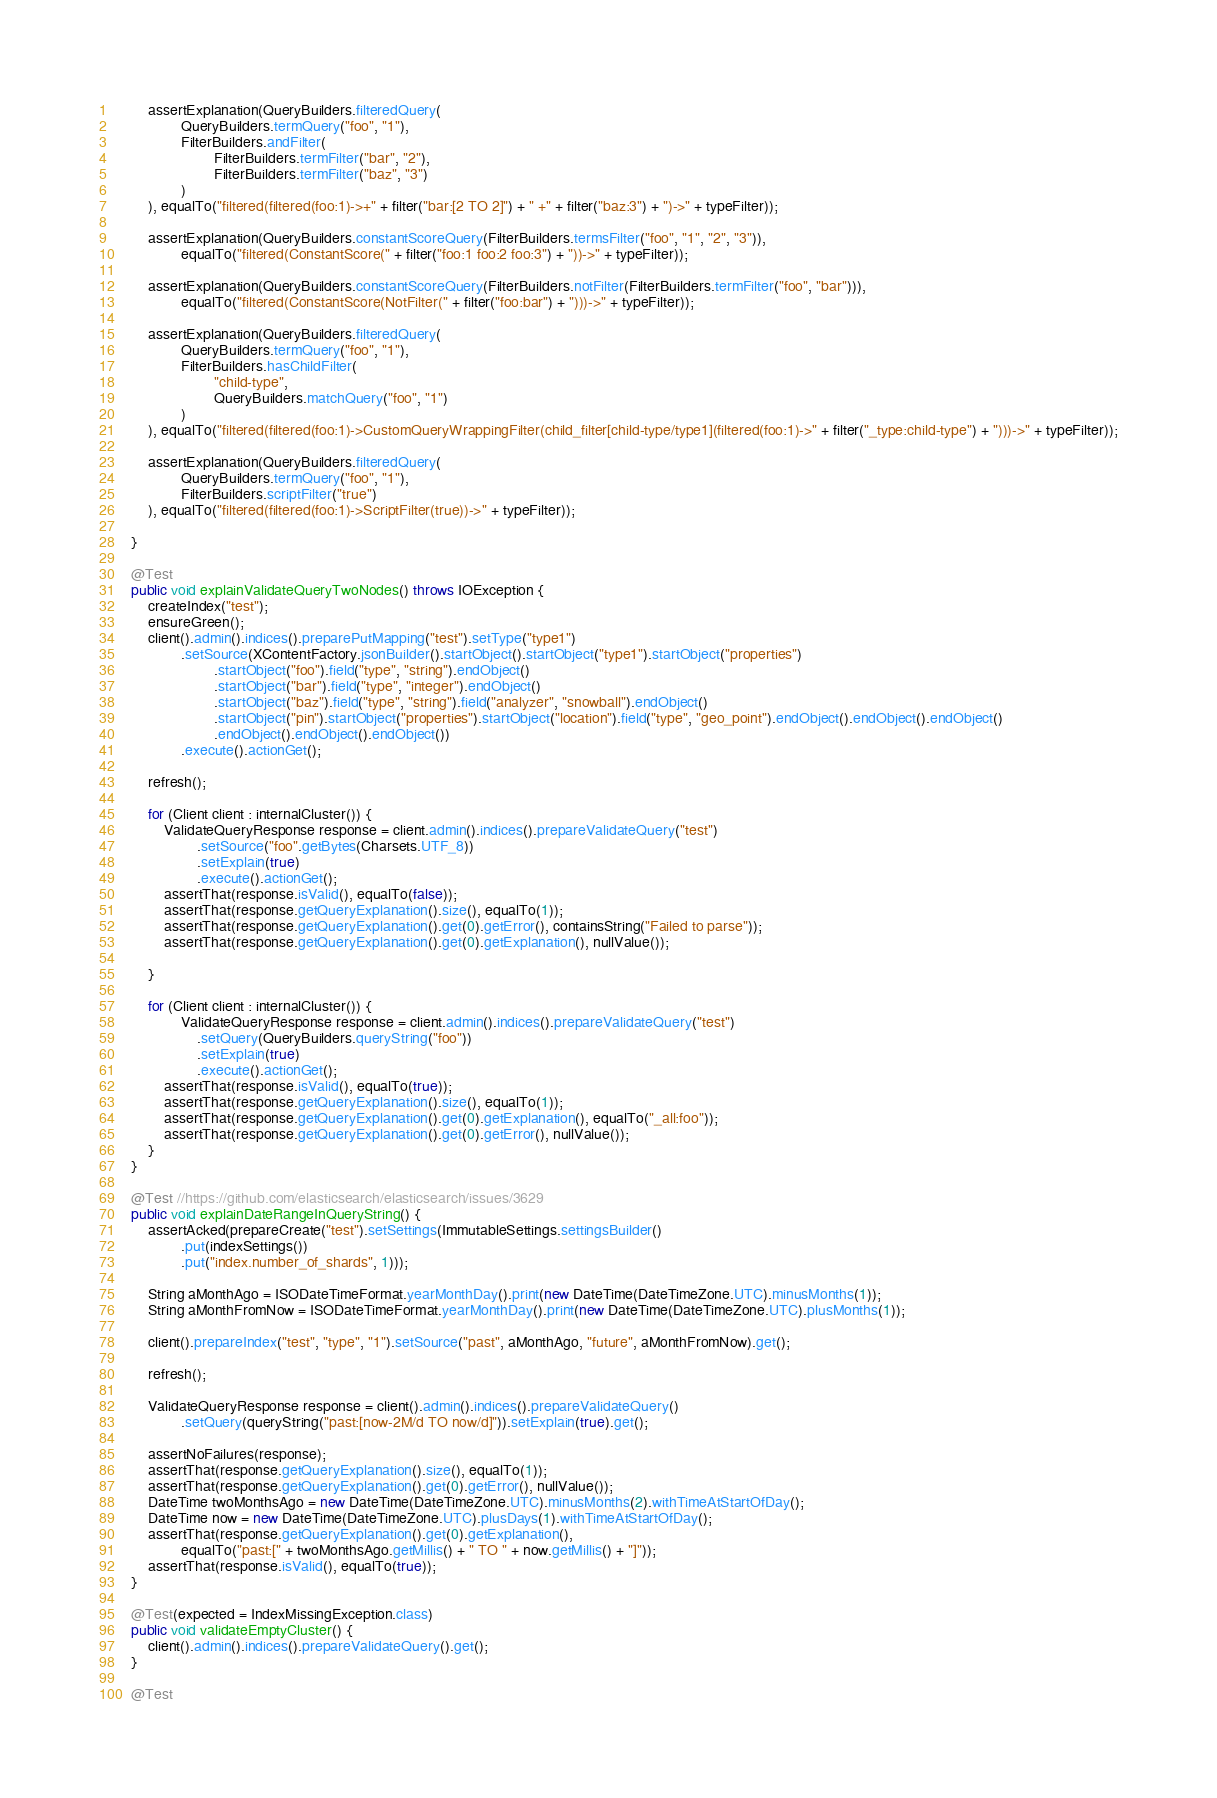<code> <loc_0><loc_0><loc_500><loc_500><_Java_>        assertExplanation(QueryBuilders.filteredQuery(
                QueryBuilders.termQuery("foo", "1"),
                FilterBuilders.andFilter(
                        FilterBuilders.termFilter("bar", "2"),
                        FilterBuilders.termFilter("baz", "3")
                )
        ), equalTo("filtered(filtered(foo:1)->+" + filter("bar:[2 TO 2]") + " +" + filter("baz:3") + ")->" + typeFilter));

        assertExplanation(QueryBuilders.constantScoreQuery(FilterBuilders.termsFilter("foo", "1", "2", "3")),
                equalTo("filtered(ConstantScore(" + filter("foo:1 foo:2 foo:3") + "))->" + typeFilter));

        assertExplanation(QueryBuilders.constantScoreQuery(FilterBuilders.notFilter(FilterBuilders.termFilter("foo", "bar"))),
                equalTo("filtered(ConstantScore(NotFilter(" + filter("foo:bar") + ")))->" + typeFilter));

        assertExplanation(QueryBuilders.filteredQuery(
                QueryBuilders.termQuery("foo", "1"),
                FilterBuilders.hasChildFilter(
                        "child-type",
                        QueryBuilders.matchQuery("foo", "1")
                )
        ), equalTo("filtered(filtered(foo:1)->CustomQueryWrappingFilter(child_filter[child-type/type1](filtered(foo:1)->" + filter("_type:child-type") + ")))->" + typeFilter));

        assertExplanation(QueryBuilders.filteredQuery(
                QueryBuilders.termQuery("foo", "1"),
                FilterBuilders.scriptFilter("true")
        ), equalTo("filtered(filtered(foo:1)->ScriptFilter(true))->" + typeFilter));

    }

    @Test
    public void explainValidateQueryTwoNodes() throws IOException {
        createIndex("test");
        ensureGreen();
        client().admin().indices().preparePutMapping("test").setType("type1")
                .setSource(XContentFactory.jsonBuilder().startObject().startObject("type1").startObject("properties")
                        .startObject("foo").field("type", "string").endObject()
                        .startObject("bar").field("type", "integer").endObject()
                        .startObject("baz").field("type", "string").field("analyzer", "snowball").endObject()
                        .startObject("pin").startObject("properties").startObject("location").field("type", "geo_point").endObject().endObject().endObject()
                        .endObject().endObject().endObject())
                .execute().actionGet();

        refresh();

        for (Client client : internalCluster()) {
            ValidateQueryResponse response = client.admin().indices().prepareValidateQuery("test")
                    .setSource("foo".getBytes(Charsets.UTF_8))
                    .setExplain(true)
                    .execute().actionGet();
            assertThat(response.isValid(), equalTo(false));
            assertThat(response.getQueryExplanation().size(), equalTo(1));
            assertThat(response.getQueryExplanation().get(0).getError(), containsString("Failed to parse"));
            assertThat(response.getQueryExplanation().get(0).getExplanation(), nullValue());

        }
        
        for (Client client : internalCluster()) {
                ValidateQueryResponse response = client.admin().indices().prepareValidateQuery("test")
                    .setQuery(QueryBuilders.queryString("foo"))
                    .setExplain(true)
                    .execute().actionGet();
            assertThat(response.isValid(), equalTo(true));
            assertThat(response.getQueryExplanation().size(), equalTo(1));
            assertThat(response.getQueryExplanation().get(0).getExplanation(), equalTo("_all:foo"));
            assertThat(response.getQueryExplanation().get(0).getError(), nullValue());
        }
    }

    @Test //https://github.com/elasticsearch/elasticsearch/issues/3629
    public void explainDateRangeInQueryString() {
        assertAcked(prepareCreate("test").setSettings(ImmutableSettings.settingsBuilder()
                .put(indexSettings())
                .put("index.number_of_shards", 1)));

        String aMonthAgo = ISODateTimeFormat.yearMonthDay().print(new DateTime(DateTimeZone.UTC).minusMonths(1));
        String aMonthFromNow = ISODateTimeFormat.yearMonthDay().print(new DateTime(DateTimeZone.UTC).plusMonths(1));

        client().prepareIndex("test", "type", "1").setSource("past", aMonthAgo, "future", aMonthFromNow).get();

        refresh();

        ValidateQueryResponse response = client().admin().indices().prepareValidateQuery()
                .setQuery(queryString("past:[now-2M/d TO now/d]")).setExplain(true).get();

        assertNoFailures(response);
        assertThat(response.getQueryExplanation().size(), equalTo(1));
        assertThat(response.getQueryExplanation().get(0).getError(), nullValue());
        DateTime twoMonthsAgo = new DateTime(DateTimeZone.UTC).minusMonths(2).withTimeAtStartOfDay();
        DateTime now = new DateTime(DateTimeZone.UTC).plusDays(1).withTimeAtStartOfDay();
        assertThat(response.getQueryExplanation().get(0).getExplanation(),
                equalTo("past:[" + twoMonthsAgo.getMillis() + " TO " + now.getMillis() + "]"));
        assertThat(response.isValid(), equalTo(true));
    }

    @Test(expected = IndexMissingException.class)
    public void validateEmptyCluster() {
        client().admin().indices().prepareValidateQuery().get();
    }

    @Test</code> 